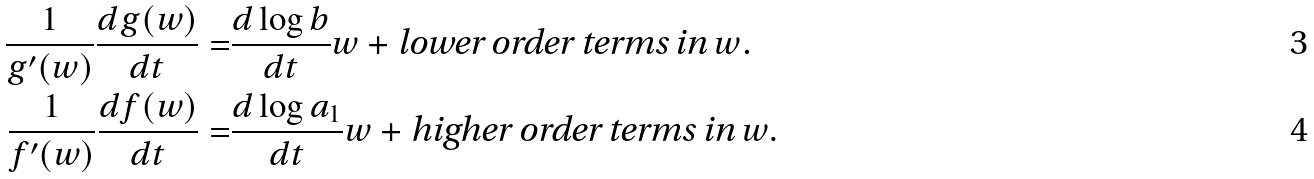Convert formula to latex. <formula><loc_0><loc_0><loc_500><loc_500>\frac { 1 } { g ^ { \prime } ( w ) } \frac { d g ( w ) } { d t } = & \frac { d \log b } { d t } w + \text {lower order terms in $w$.} \\ \frac { 1 } { f ^ { \prime } ( w ) } \frac { d f ( w ) } { d t } = & \frac { d \log a _ { 1 } } { d t } w + \text {higher order terms in $w$} .</formula> 